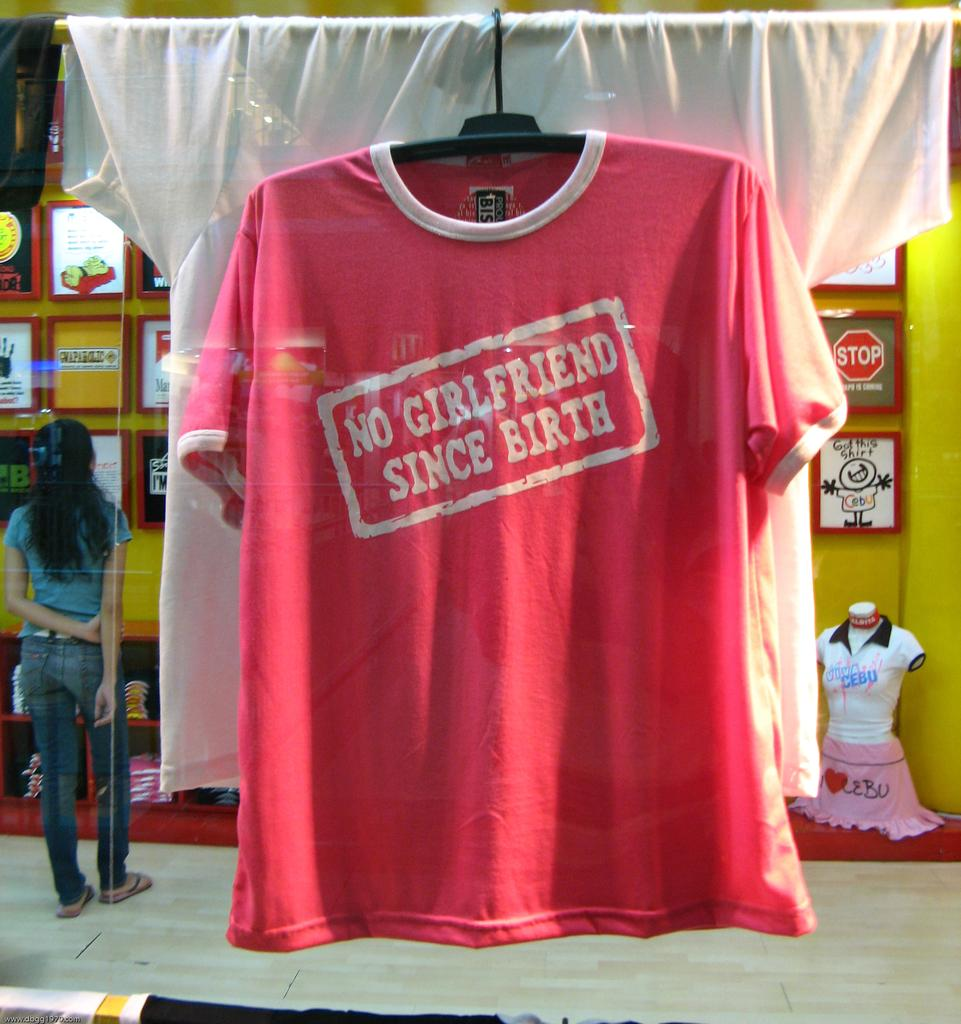Provide a one-sentence caption for the provided image. A picture of a shirt on a hanger talking about the wearer being single. 